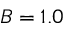<formula> <loc_0><loc_0><loc_500><loc_500>B = 1 . 0</formula> 